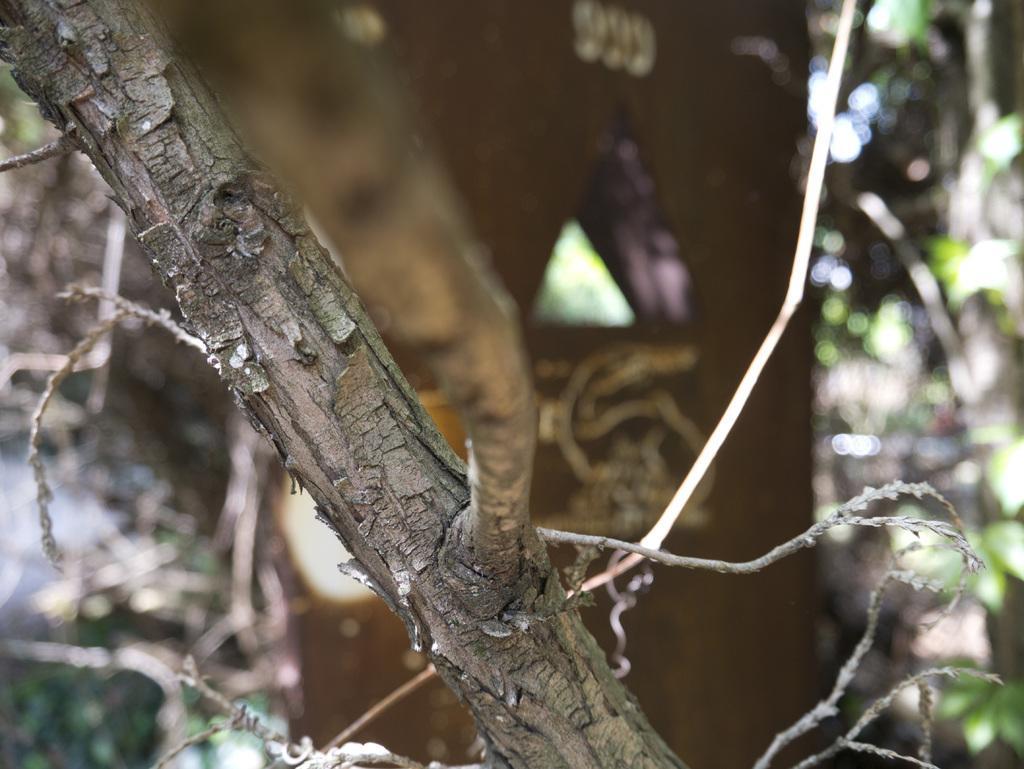Please provide a concise description of this image. In the image we can see these are tree branches and the background is blurred. 